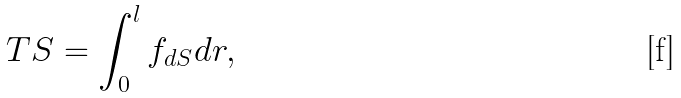Convert formula to latex. <formula><loc_0><loc_0><loc_500><loc_500>T S = \int _ { 0 } ^ { l } { f } _ { d S } d r ,</formula> 